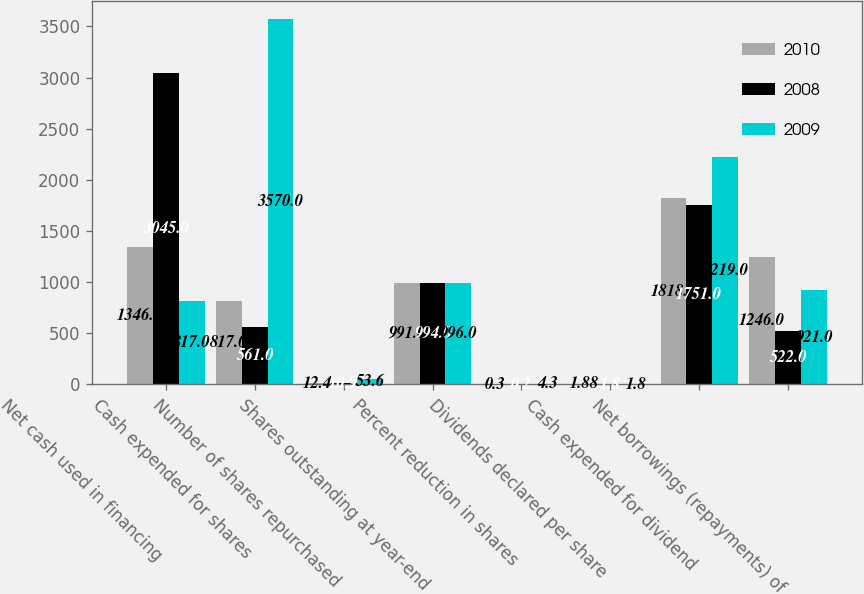Convert chart. <chart><loc_0><loc_0><loc_500><loc_500><stacked_bar_chart><ecel><fcel>Net cash used in financing<fcel>Cash expended for shares<fcel>Number of shares repurchased<fcel>Shares outstanding at year-end<fcel>Percent reduction in shares<fcel>Dividends declared per share<fcel>Cash expended for dividend<fcel>Net borrowings (repayments) of<nl><fcel>2010<fcel>1346<fcel>817<fcel>12.4<fcel>991<fcel>0.3<fcel>1.88<fcel>1818<fcel>1246<nl><fcel>2008<fcel>3045<fcel>561<fcel>10.9<fcel>994<fcel>0.2<fcel>1.8<fcel>1751<fcel>522<nl><fcel>2009<fcel>817<fcel>3570<fcel>53.6<fcel>996<fcel>4.3<fcel>1.8<fcel>2219<fcel>921<nl></chart> 